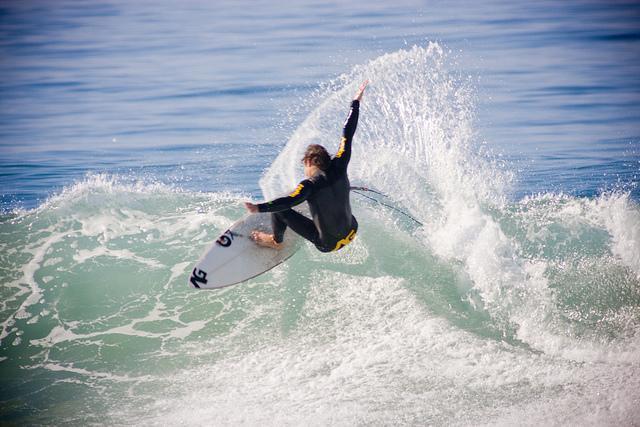How many horses in this picture do not have white feet?
Give a very brief answer. 0. 